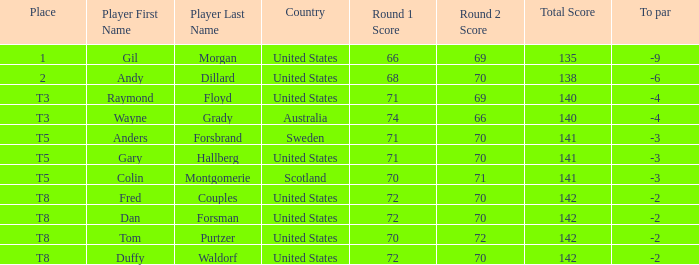What is Anders Forsbrand's Place? T5. 